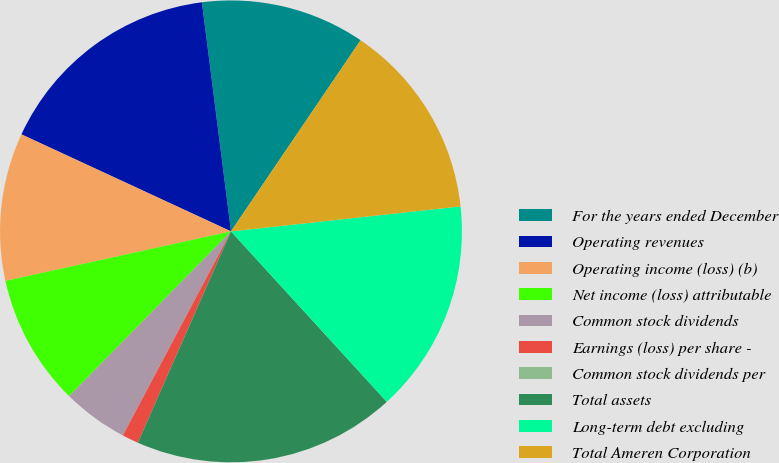Convert chart to OTSL. <chart><loc_0><loc_0><loc_500><loc_500><pie_chart><fcel>For the years ended December<fcel>Operating revenues<fcel>Operating income (loss) (b)<fcel>Net income (loss) attributable<fcel>Common stock dividends<fcel>Earnings (loss) per share -<fcel>Common stock dividends per<fcel>Total assets<fcel>Long-term debt excluding<fcel>Total Ameren Corporation<nl><fcel>11.49%<fcel>16.09%<fcel>10.34%<fcel>9.2%<fcel>4.6%<fcel>1.15%<fcel>0.0%<fcel>18.39%<fcel>14.94%<fcel>13.79%<nl></chart> 